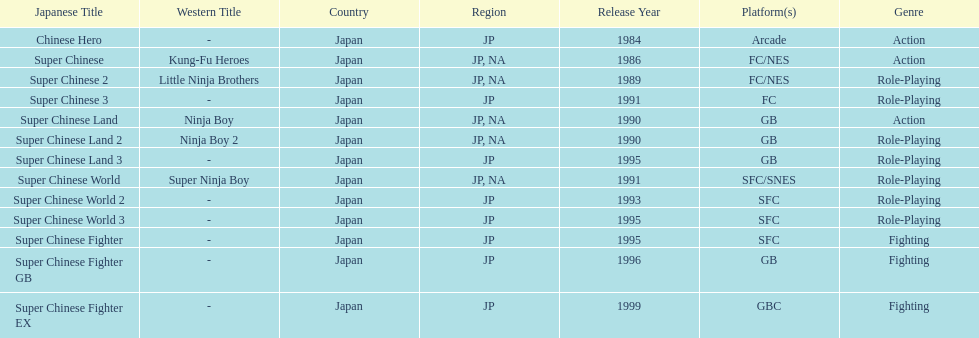Of the titles released in north america, which had the least releases? Super Chinese World. 